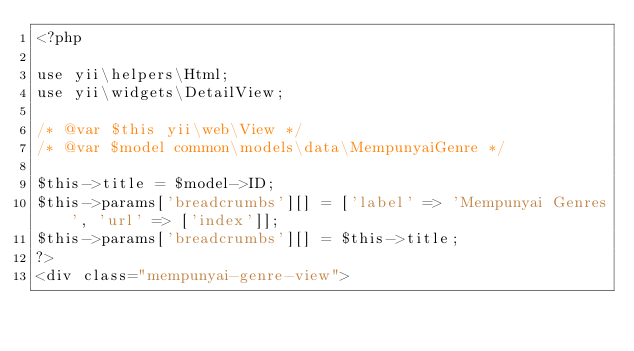<code> <loc_0><loc_0><loc_500><loc_500><_PHP_><?php

use yii\helpers\Html;
use yii\widgets\DetailView;

/* @var $this yii\web\View */
/* @var $model common\models\data\MempunyaiGenre */

$this->title = $model->ID;
$this->params['breadcrumbs'][] = ['label' => 'Mempunyai Genres', 'url' => ['index']];
$this->params['breadcrumbs'][] = $this->title;
?>
<div class="mempunyai-genre-view">
</code> 